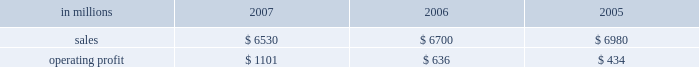Customer demand .
This compared with 555000 tons of total downtime in 2006 of which 150000 tons related to lack-of-orders .
Printing papers in millions 2007 2006 2005 .
North american printing papers net sales in 2007 were $ 3.5 billion compared with $ 4.4 billion in 2006 ( $ 3.5 billion excluding the coated and super- calendered papers business ) and $ 4.8 billion in 2005 ( $ 3.2 billion excluding the coated and super- calendered papers business ) .
Sales volumes decreased in 2007 versus 2006 partially due to reduced production capacity resulting from the conversion of the paper machine at the pensacola mill to the production of lightweight linerboard for our industrial packaging segment .
Average sales price realizations increased significantly , reflecting benefits from price increases announced throughout 2007 .
Lack-of-order downtime declined to 27000 tons in 2007 from 40000 tons in 2006 .
Operating earnings of $ 537 million in 2007 increased from $ 482 million in 2006 ( $ 407 million excluding the coated and supercalendered papers business ) and $ 175 million in 2005 ( $ 74 million excluding the coated and supercalendered papers business ) .
The benefits from improved average sales price realizations more than offset the effects of higher input costs for wood , energy , and freight .
Mill operations were favorable compared with the prior year due to current-year improvements in machine performance and energy conservation efforts .
Sales volumes for the first quarter of 2008 are expected to increase slightly , and the mix of prod- ucts sold to improve .
Demand for printing papers in north america was steady as the quarter began .
Price increases for cut-size paper and roll stock have been announced that are expected to be effective principally late in the first quarter .
Planned mill maintenance outage costs should be about the same as in the fourth quarter ; however , raw material costs are expected to continue to increase , primarily for wood and energy .
Brazil ian papers net sales for 2007 of $ 850 mil- lion were higher than the $ 495 million in 2006 and the $ 465 million in 2005 .
Compared with 2006 , aver- age sales price realizations improved reflecting price increases for uncoated freesheet paper realized dur- ing the second half of 2006 and the first half of 2007 .
Excluding the impact of the luiz antonio acquisition , sales volumes increased primarily for cut size and offset paper .
Operating profits for 2007 of $ 246 mil- lion were up from $ 122 million in 2006 and $ 134 mil- lion in 2005 as the benefits from higher sales prices and favorable manufacturing costs were only parti- ally offset by higher input costs .
Contributions from the luiz antonio acquisition increased net sales by approximately $ 350 million and earnings by approx- imately $ 80 million in 2007 .
Entering 2008 , sales volumes for uncoated freesheet paper and pulp should be seasonally lower .
Average price realizations should be essentially flat , but mar- gins are expected to reflect a less favorable product mix .
Energy costs , primarily for hydroelectric power , are expected to increase significantly reflecting a lack of rainfall in brazil in the latter part of 2007 .
European papers net sales in 2007 were $ 1.5 bil- lion compared with $ 1.3 billion in 2006 and $ 1.2 bil- lion in 2005 .
Sales volumes in 2007 were higher than in 2006 at our eastern european mills reflecting stronger market demand and improved efficiencies , but lower in western europe reflecting the closure of the marasquel mill in 2006 .
Average sales price real- izations increased significantly in 2007 in both east- ern and western european markets .
Operating profits of $ 214 million in 2007 increased from a loss of $ 16 million in 2006 and earnings of $ 88 million in 2005 .
The loss in 2006 reflects the impact of a $ 128 million impairment charge to reduce the carrying value of the fixed assets at the saillat , france mill .
Excluding this charge , the improvement in 2007 compared with 2006 reflects the contribution from higher net sales , partially offset by higher input costs for wood , energy and freight .
Looking ahead to the first quarter of 2008 , sales volumes are expected to be stable in western europe , but seasonally weaker in eastern europe and russia .
Average price realizations are expected to remain about flat .
Wood costs are expected to increase , especially in russia due to strong demand ahead of tariff increases , and energy costs are anticipated to be seasonally higher .
Asian printing papers net sales were approx- imately $ 20 million in 2007 , compared with $ 15 mil- lion in 2006 and $ 10 million in 2005 .
Operating earnings increased slightly in 2007 , but were close to breakeven in all periods .
U.s .
Market pulp sales in 2007 totaled $ 655 mil- lion compared with $ 510 million and $ 525 million in 2006 and 2005 , respectively .
Sales volumes in 2007 were up from 2006 levels , primarily for paper and .
What percent of printing papers sales in 2007 was from north american printing papers net sales? 
Computations: ((3.5 * 1000) / 6530)
Answer: 0.53599. 